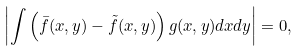Convert formula to latex. <formula><loc_0><loc_0><loc_500><loc_500>\left | \int \left ( \bar { f } ( x , y ) - \tilde { f } ( x , y ) \right ) g ( x , y ) d x d y \right | = 0 ,</formula> 